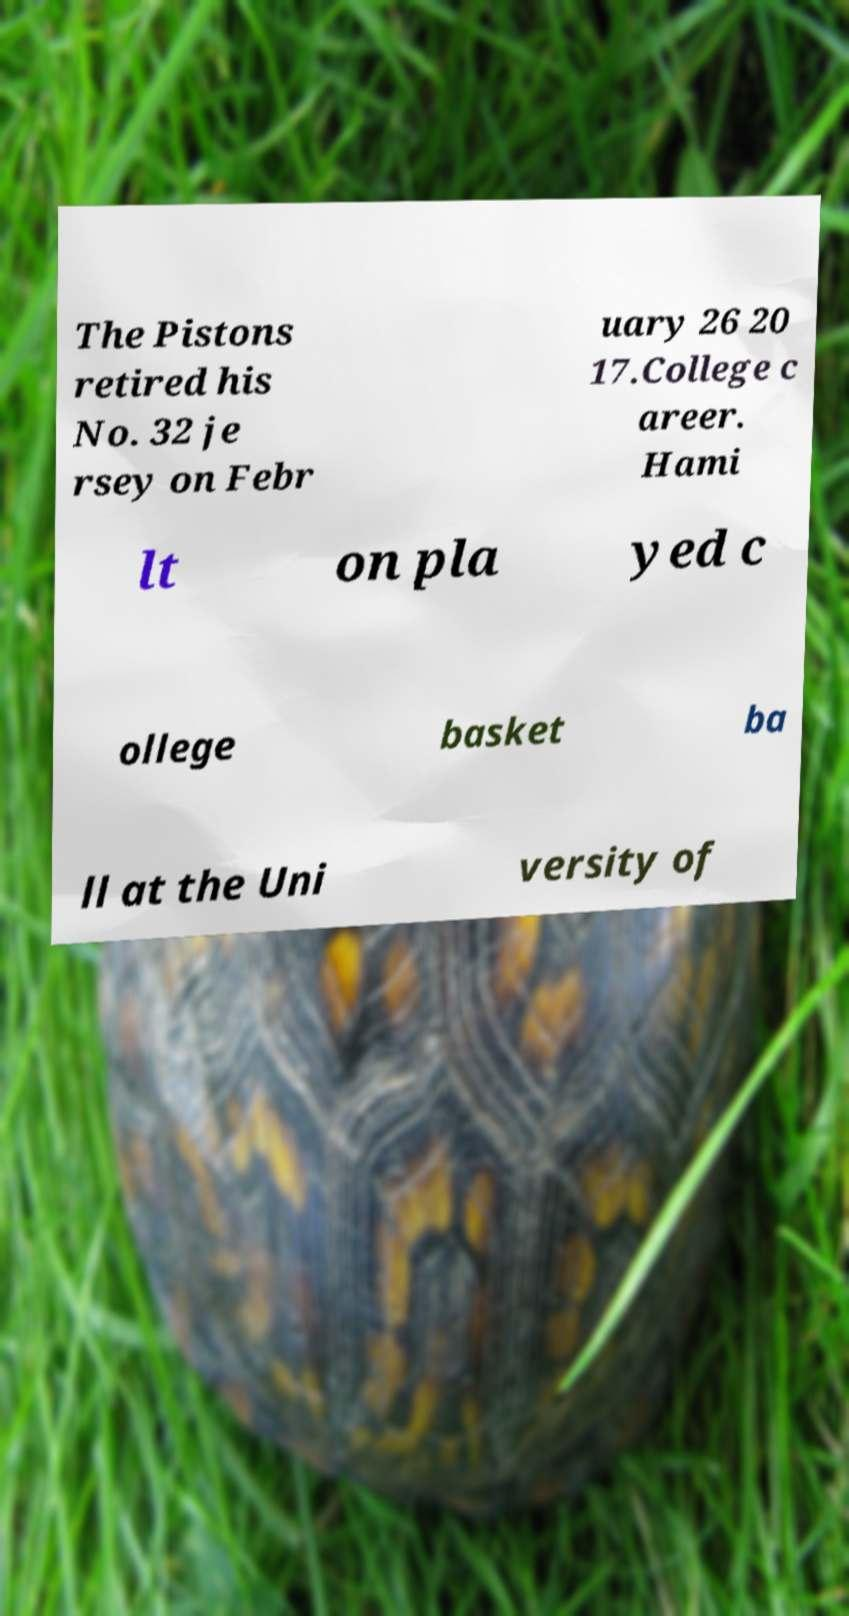Please identify and transcribe the text found in this image. The Pistons retired his No. 32 je rsey on Febr uary 26 20 17.College c areer. Hami lt on pla yed c ollege basket ba ll at the Uni versity of 